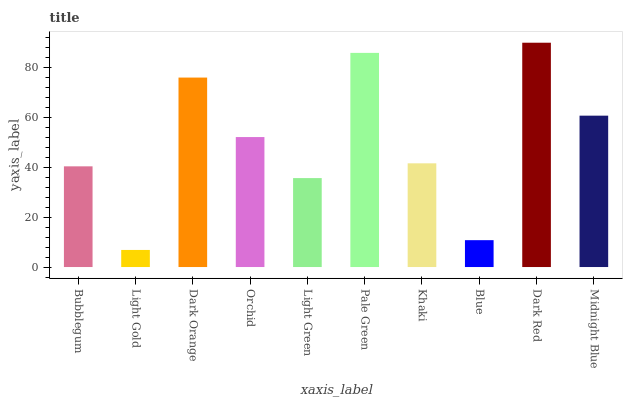Is Light Gold the minimum?
Answer yes or no. Yes. Is Dark Red the maximum?
Answer yes or no. Yes. Is Dark Orange the minimum?
Answer yes or no. No. Is Dark Orange the maximum?
Answer yes or no. No. Is Dark Orange greater than Light Gold?
Answer yes or no. Yes. Is Light Gold less than Dark Orange?
Answer yes or no. Yes. Is Light Gold greater than Dark Orange?
Answer yes or no. No. Is Dark Orange less than Light Gold?
Answer yes or no. No. Is Orchid the high median?
Answer yes or no. Yes. Is Khaki the low median?
Answer yes or no. Yes. Is Light Green the high median?
Answer yes or no. No. Is Pale Green the low median?
Answer yes or no. No. 